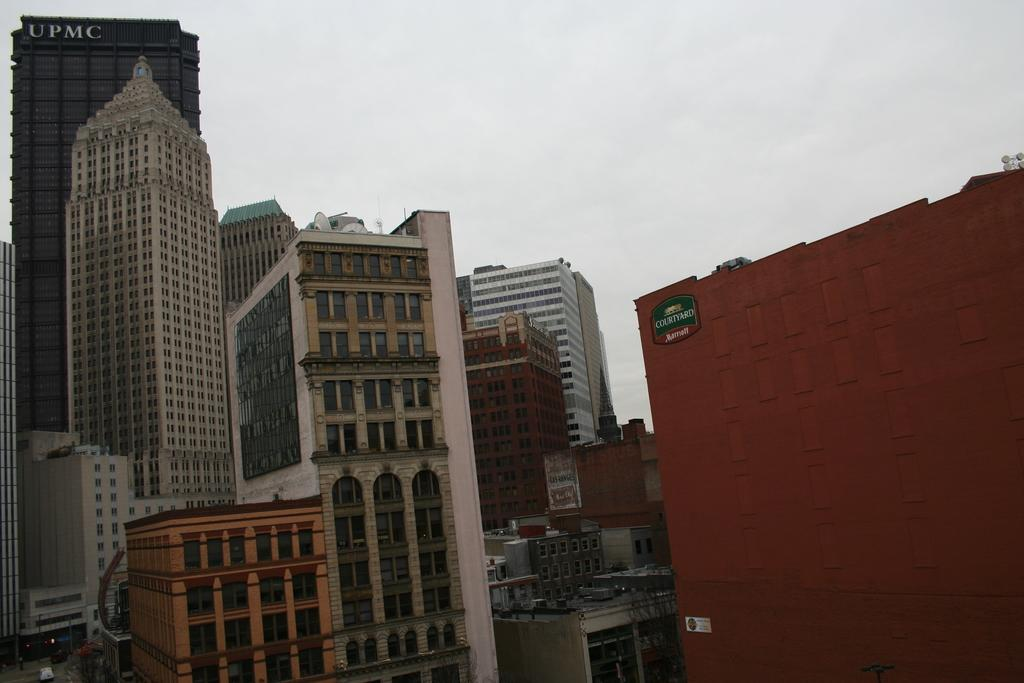What structures are present in the image? There are buildings in the image. What can be seen in the background of the image? The sky is visible in the background of the image. What type of ink is used to draw the vase in the image? There is no vase present in the image, and therefore no ink can be associated with it. 